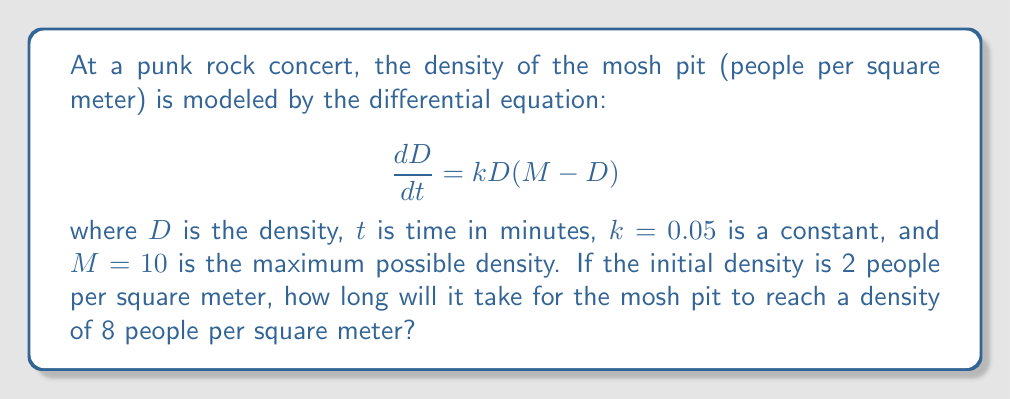Help me with this question. 1. We start with the given differential equation:
   $$\frac{dD}{dt} = kD(M-D)$$

2. Substitute the given values: $k=0.05$, $M=10$
   $$\frac{dD}{dt} = 0.05D(10-D)$$

3. This is a separable differential equation. Rearrange it:
   $$\frac{dD}{D(10-D)} = 0.05dt$$

4. Integrate both sides:
   $$\int \frac{dD}{D(10-D)} = \int 0.05dt$$

5. The left side can be integrated using partial fractions:
   $$\frac{1}{10}\ln|D| - \frac{1}{10}\ln|10-D| = 0.05t + C$$

6. Apply the initial condition: $D=2$ when $t=0$
   $$\frac{1}{10}\ln(2) - \frac{1}{10}\ln(8) = C$$

7. Now, we want to find $t$ when $D=8$. Substitute this into our equation:
   $$\frac{1}{10}\ln(8) - \frac{1}{10}\ln(2) = 0.05t + \frac{1}{10}\ln(2) - \frac{1}{10}\ln(8)$$

8. Simplify:
   $$\frac{1}{5}\ln(4) = 0.05t$$

9. Solve for $t$:
   $$t = \frac{\ln(4)}{0.25} = 4\ln(4) \approx 5.55$$

Therefore, it will take approximately 5.55 minutes for the mosh pit to reach a density of 8 people per square meter.
Answer: $4\ln(4)$ minutes (≈ 5.55 minutes) 